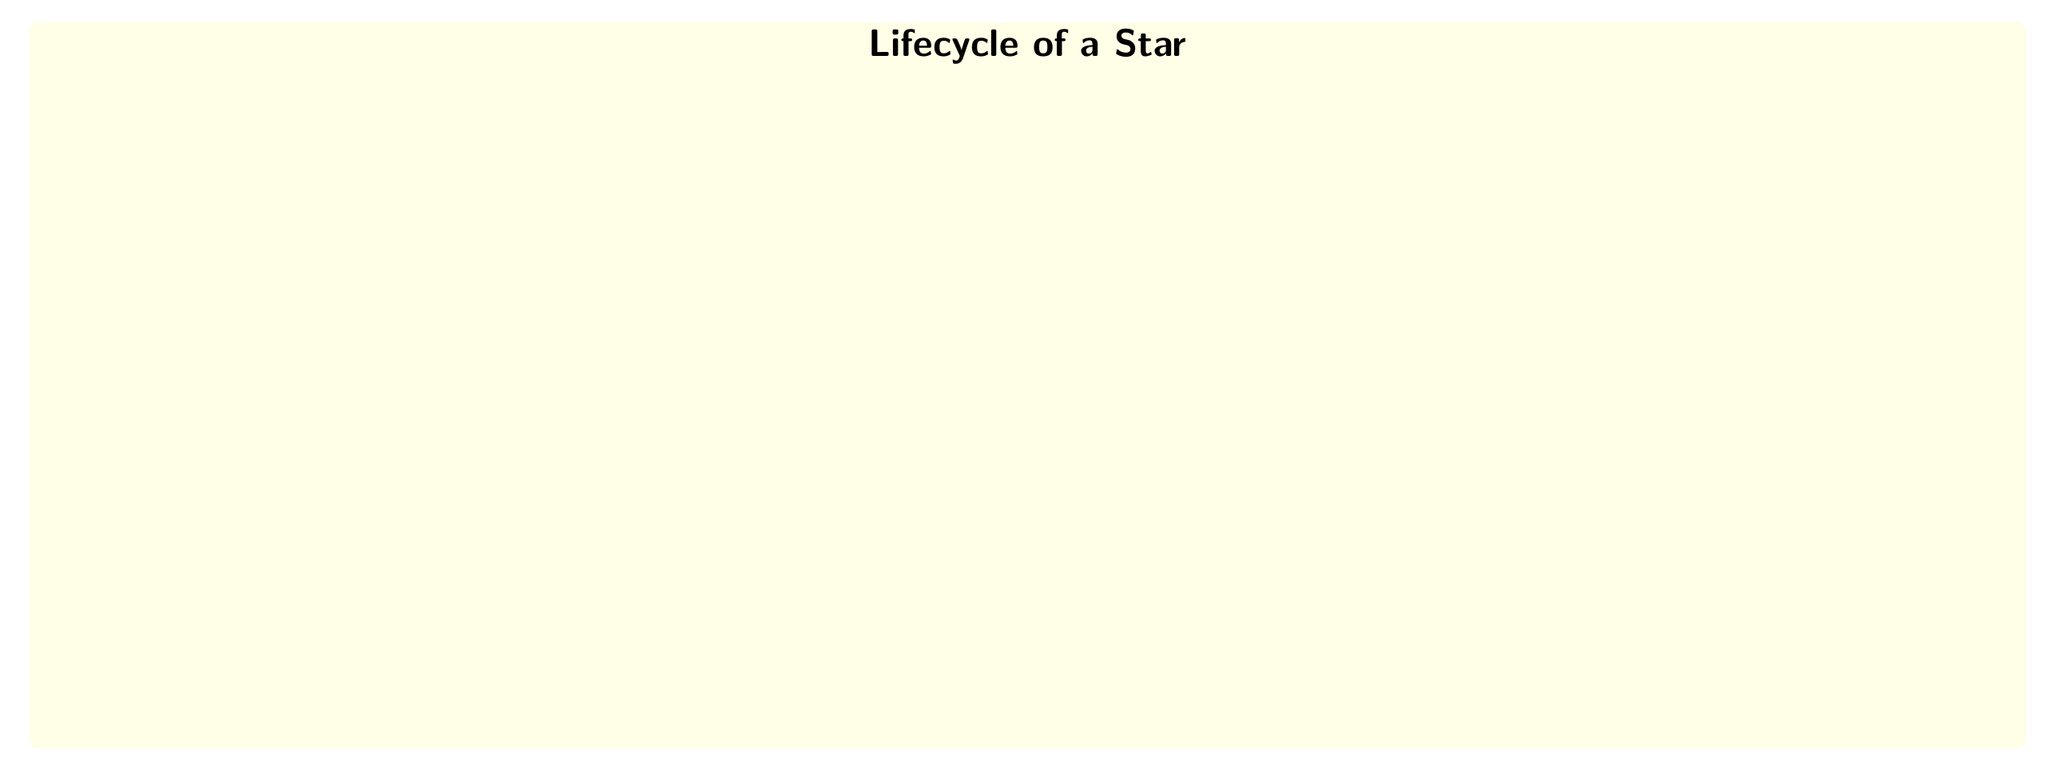What is the first stage in the lifecycle of a star? The diagram starts with the node labeled "Nebula," which is identified as the first stage in the lifecycle of a star.
Answer: Nebula How many main stages are there in the lifecycle of a star? The diagram shows a total of seven nodes, indicating the main stages in the lifecycle of a star. Thus, the main stages include Nebula, Protostar, Main Sequence Star, Red Giant, Supernova, Black Hole, and White Dwarf.
Answer: Seven What does a star become after the Main Sequence Star stage? According to the flowchart, after the Main Sequence Star stage, a star transitions into the Red Giant stage. The flow is directed from "Main Sequence Star" to "Red Giant."
Answer: Red Giant What happens to a massive star after it becomes a Red Giant? The flowchart indicates that for massive stars, after becoming a Red Giant, the next stage is a Supernova, which is represented directly below the Red Giant node.
Answer: Supernova What is the final outcome for low to medium mass stars? The diagram illustrates that low to medium mass stars end their lifecycle by becoming a White Dwarf after the Red Giant stage. This is indicated by the flow directing from Red Giant to White Dwarf.
Answer: White Dwarf Which event is associated with core collapse in the lifecycle of a star? In the diagram, the node labeled Supernova connects to the Black Hole node through the label "Core collapse," indicating that the Supernova event is associated with the core collapse for massive stars.
Answer: Core collapse 